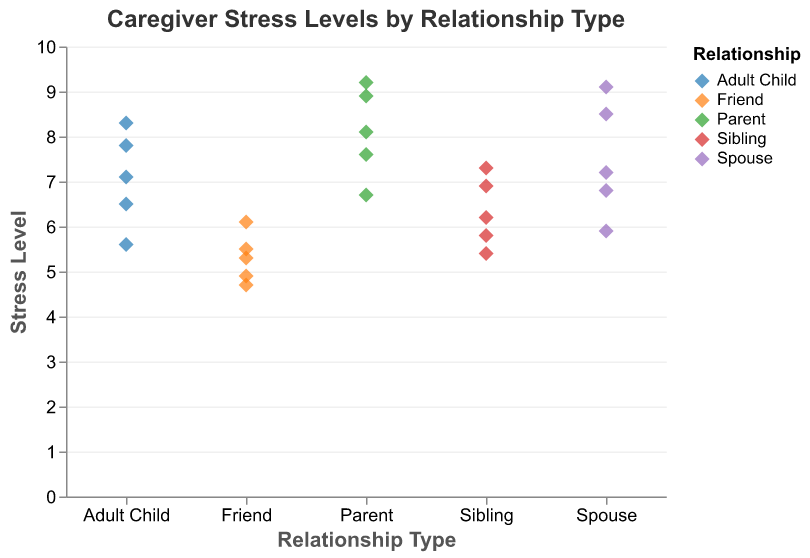What is the title of the figure? The title is the text at the top of the figure, usually providing a succinct summary of what the plot represents. In this case, the title is clearly stated in the code.
Answer: Caregiver Stress Levels by Relationship Type Which relationship type has the highest single reported stress level? To determine the highest single reported stress level, look for the data point with the maximum value on the y-axis and identify its corresponding x-axis category.
Answer: Parent Which relationship type has the lowest single reported stress level? To find the lowest single reported stress level, identify the data point with the minimum y-axis value and note its x-axis category.
Answer: Friend What is the range of stress levels reported by caregivers who are siblings? The range is calculated by subtracting the minimum value from the maximum value within the Sibling category on the y-axis. The minimum value for Sibling is 5.4 and the maximum is 7.3.
Answer: 1.9 Which relationship type shows the greatest variation in stress levels? Variation in stress levels can be identified by examining the spread of the data points for each category. Greater variation will show a larger spread on the y-axis.
Answer: Parent How many data points are there for the Spouse caregivers? Count the number of individual points for the Spouse category on the x-axis. There are clearly 5 points plotted for Spouse.
Answer: 5 What is the average stress level reported by Adult Child caregivers? Add up all the stress levels for Adult Child and divide by the number of data points in this category: (6.5 + 7.8 + 5.6 + 8.3 + 7.1) / 5 = 7.06.
Answer: 7.06 Which two relationship types have the closest average stress levels? Calculate the average stress level for each relationship type, then compare these averages to identify the two closest ones. The calculations show that Sibling (6.32) and Adult Child (7.06) are the closest.
Answer: Sibling and Adult Child Is there any overlap in stress levels between the Friend and Spouse caregiver categories? Compare the range of stress levels for Friend (4.7 to 6.1) and Spouse (5.9 to 9.1) to see if any values are common to both. The overlapping range is from 5.9 to 6.1.
Answer: Yes Based on the figure, which relationship type experiences generally lower stress levels? Identify the relationship type with the lower average stress levels and less spread of higher values. Friend caregivers have lower stress levels overall (range 4.7 to 6.1).
Answer: Friend 